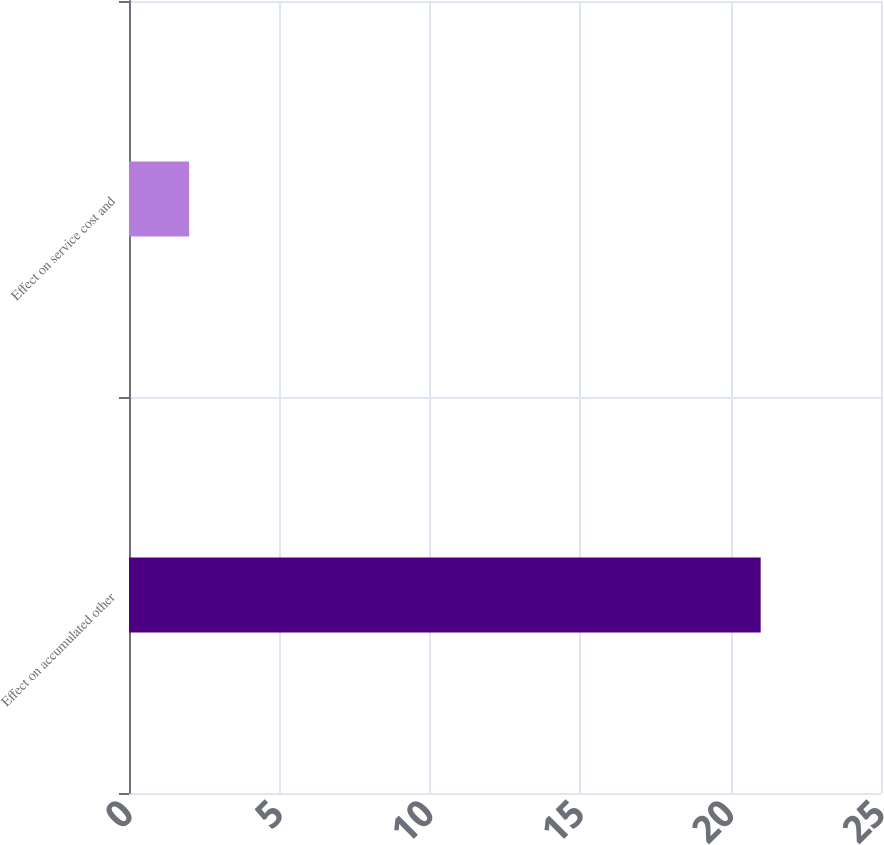<chart> <loc_0><loc_0><loc_500><loc_500><bar_chart><fcel>Effect on accumulated other<fcel>Effect on service cost and<nl><fcel>21<fcel>2<nl></chart> 